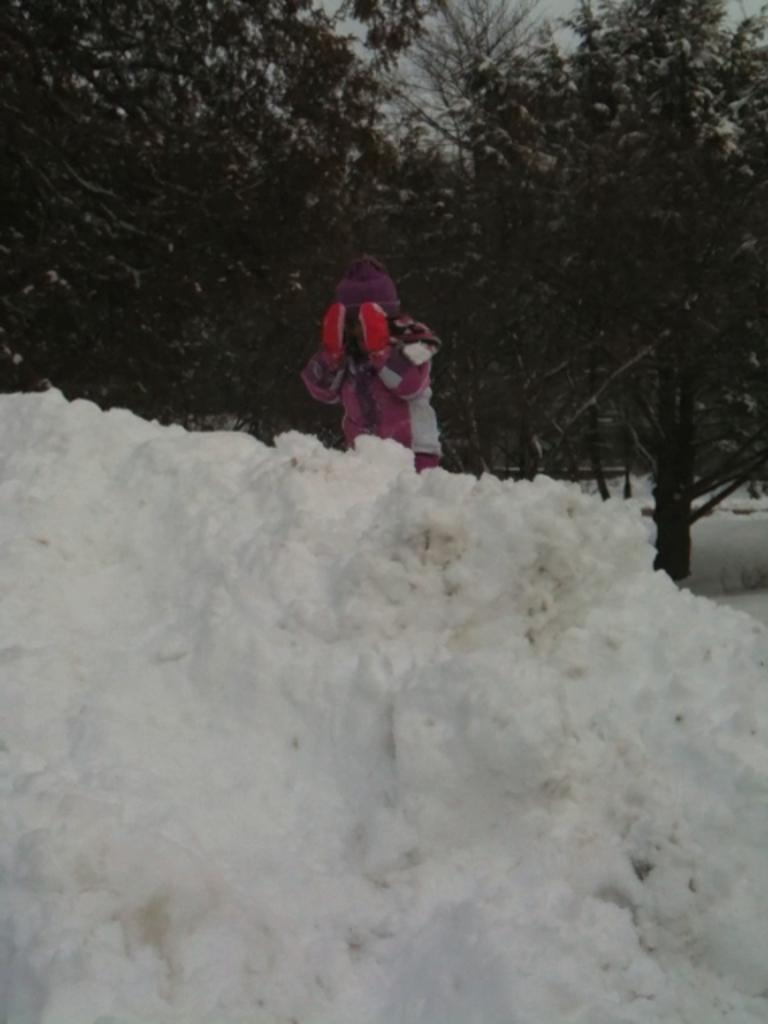Who or what is present in the image? There is a person in the image. What is the weather like in the image? There is snow visible in the image, indicating a cold and likely wintery scene. What type of natural environment can be seen in the image? There are trees in the image, suggesting a forest or wooded area. What is visible in the background of the image? The sky is visible in the image. What is the relation between the person and the nation in the image? There is no information about a nation or any relation in the image; it only shows a person in a snowy environment with trees and sky. 